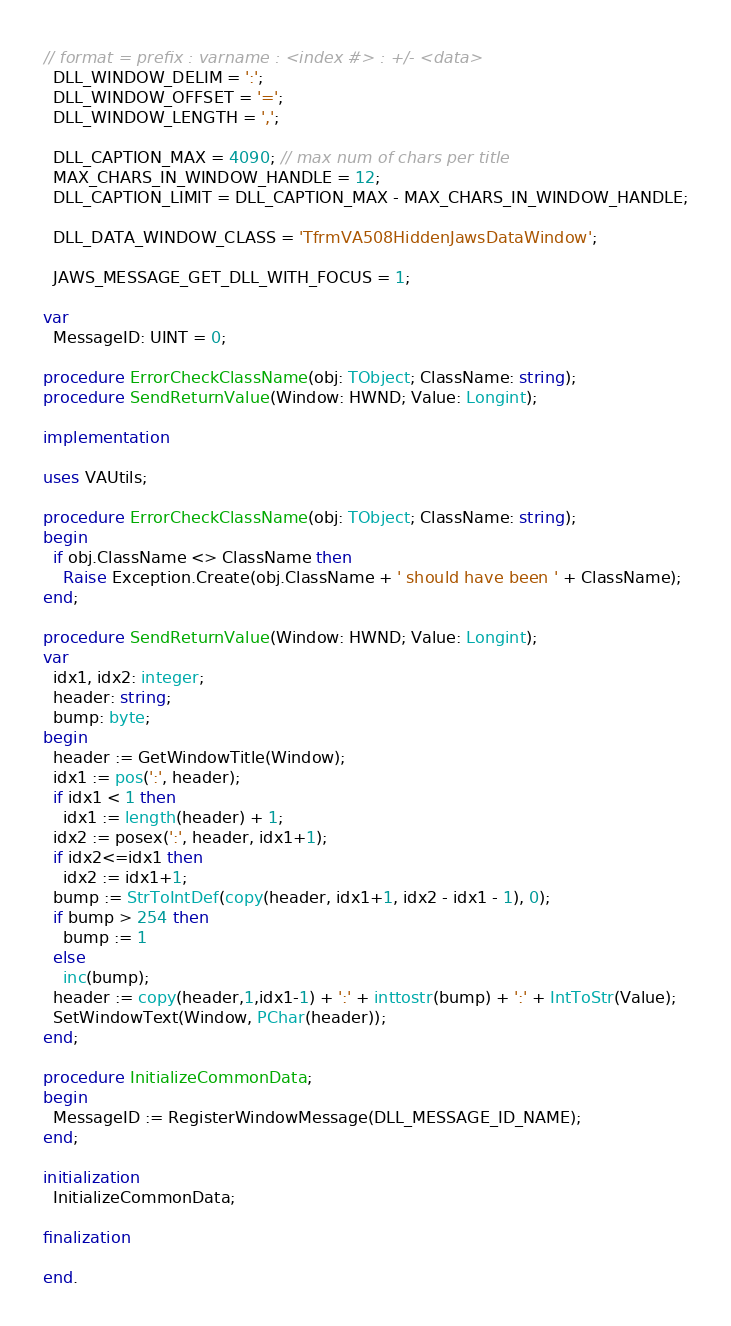<code> <loc_0><loc_0><loc_500><loc_500><_Pascal_>
// format = prefix : varname : <index #> : +/- <data>
  DLL_WINDOW_DELIM = ':';
  DLL_WINDOW_OFFSET = '=';
  DLL_WINDOW_LENGTH = ',';

  DLL_CAPTION_MAX = 4090; // max num of chars per title
  MAX_CHARS_IN_WINDOW_HANDLE = 12;
  DLL_CAPTION_LIMIT = DLL_CAPTION_MAX - MAX_CHARS_IN_WINDOW_HANDLE;

  DLL_DATA_WINDOW_CLASS = 'TfrmVA508HiddenJawsDataWindow';
  
  JAWS_MESSAGE_GET_DLL_WITH_FOCUS = 1;

var
  MessageID: UINT = 0;

procedure ErrorCheckClassName(obj: TObject; ClassName: string);
procedure SendReturnValue(Window: HWND; Value: Longint);

implementation

uses VAUtils;

procedure ErrorCheckClassName(obj: TObject; ClassName: string);
begin
  if obj.ClassName <> ClassName then
    Raise Exception.Create(obj.ClassName + ' should have been ' + ClassName);
end;

procedure SendReturnValue(Window: HWND; Value: Longint);
var
  idx1, idx2: integer;
  header: string;
  bump: byte;
begin
  header := GetWindowTitle(Window);
  idx1 := pos(':', header);
  if idx1 < 1 then
    idx1 := length(header) + 1;
  idx2 := posex(':', header, idx1+1);
  if idx2<=idx1 then
    idx2 := idx1+1;
  bump := StrToIntDef(copy(header, idx1+1, idx2 - idx1 - 1), 0);
  if bump > 254 then
    bump := 1
  else
    inc(bump);
  header := copy(header,1,idx1-1) + ':' + inttostr(bump) + ':' + IntToStr(Value);
  SetWindowText(Window, PChar(header));
end;

procedure InitializeCommonData;
begin
  MessageID := RegisterWindowMessage(DLL_MESSAGE_ID_NAME);
end;

initialization
  InitializeCommonData;

finalization

end.
</code> 